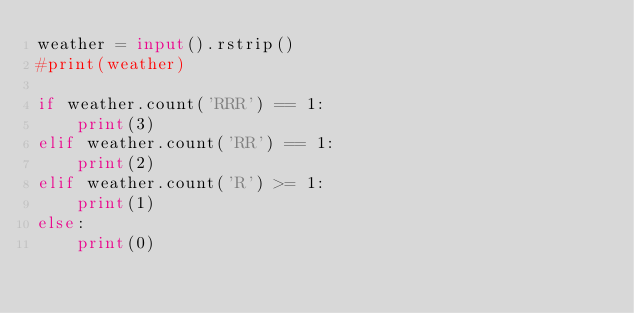Convert code to text. <code><loc_0><loc_0><loc_500><loc_500><_Python_>weather = input().rstrip()
#print(weather)

if weather.count('RRR') == 1:
    print(3)
elif weather.count('RR') == 1:
    print(2)
elif weather.count('R') >= 1:
    print(1)
else:
    print(0)</code> 